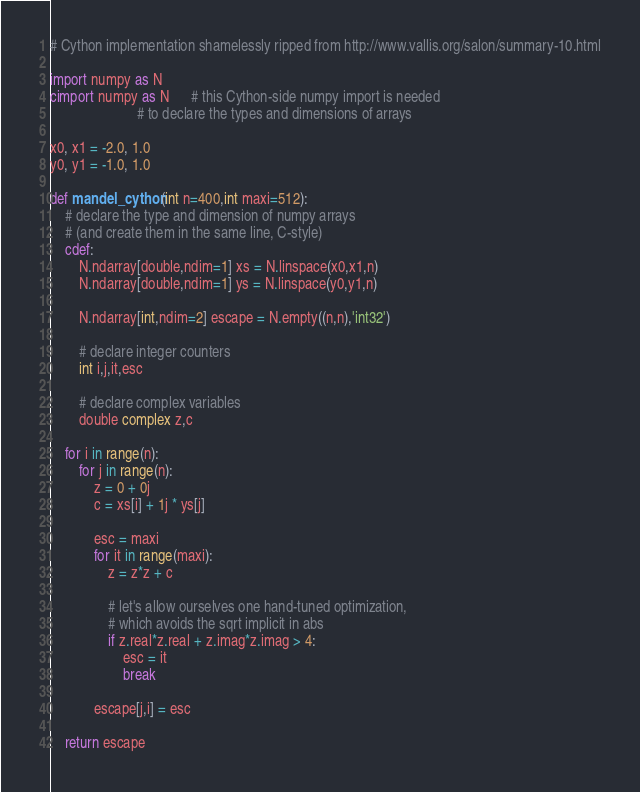Convert code to text. <code><loc_0><loc_0><loc_500><loc_500><_Cython_># Cython implementation shamelessly ripped from http://www.vallis.org/salon/summary-10.html

import numpy as N
cimport numpy as N      # this Cython-side numpy import is needed
                        # to declare the types and dimensions of arrays

x0, x1 = -2.0, 1.0
y0, y1 = -1.0, 1.0

def mandel_cython(int n=400,int maxi=512):
    # declare the type and dimension of numpy arrays
    # (and create them in the same line, C-style)
    cdef:
        N.ndarray[double,ndim=1] xs = N.linspace(x0,x1,n)
        N.ndarray[double,ndim=1] ys = N.linspace(y0,y1,n)

        N.ndarray[int,ndim=2] escape = N.empty((n,n),'int32')

        # declare integer counters
        int i,j,it,esc

        # declare complex variables
        double complex z,c

    for i in range(n):
        for j in range(n):
            z = 0 + 0j
            c = xs[i] + 1j * ys[j]

            esc = maxi
            for it in range(maxi):
                z = z*z + c

                # let's allow ourselves one hand-tuned optimization,
                # which avoids the sqrt implicit in abs
                if z.real*z.real + z.imag*z.imag > 4:
                    esc = it
                    break

            escape[j,i] = esc

    return escape
</code> 